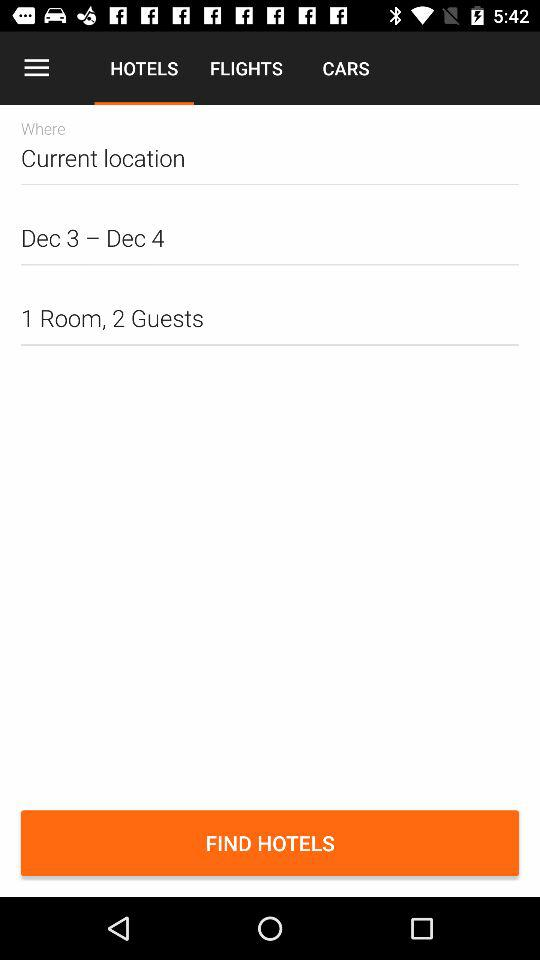How many guests are there? There are 2 guests. 